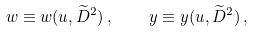Convert formula to latex. <formula><loc_0><loc_0><loc_500><loc_500>w \equiv w ( u , \widetilde { D } ^ { 2 } ) \, , \quad y \equiv y ( u , \widetilde { D } ^ { 2 } ) \, ,</formula> 